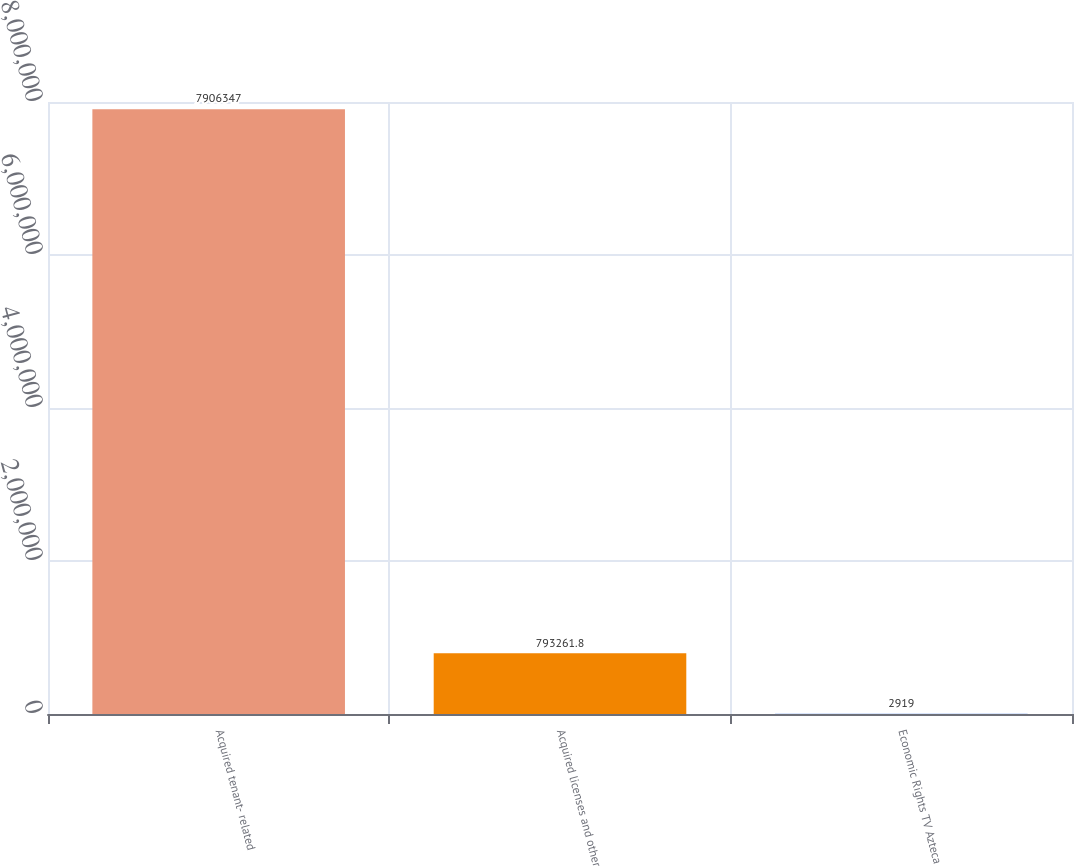<chart> <loc_0><loc_0><loc_500><loc_500><bar_chart><fcel>Acquired tenant- related<fcel>Acquired licenses and other<fcel>Economic Rights TV Azteca<nl><fcel>7.90635e+06<fcel>793262<fcel>2919<nl></chart> 